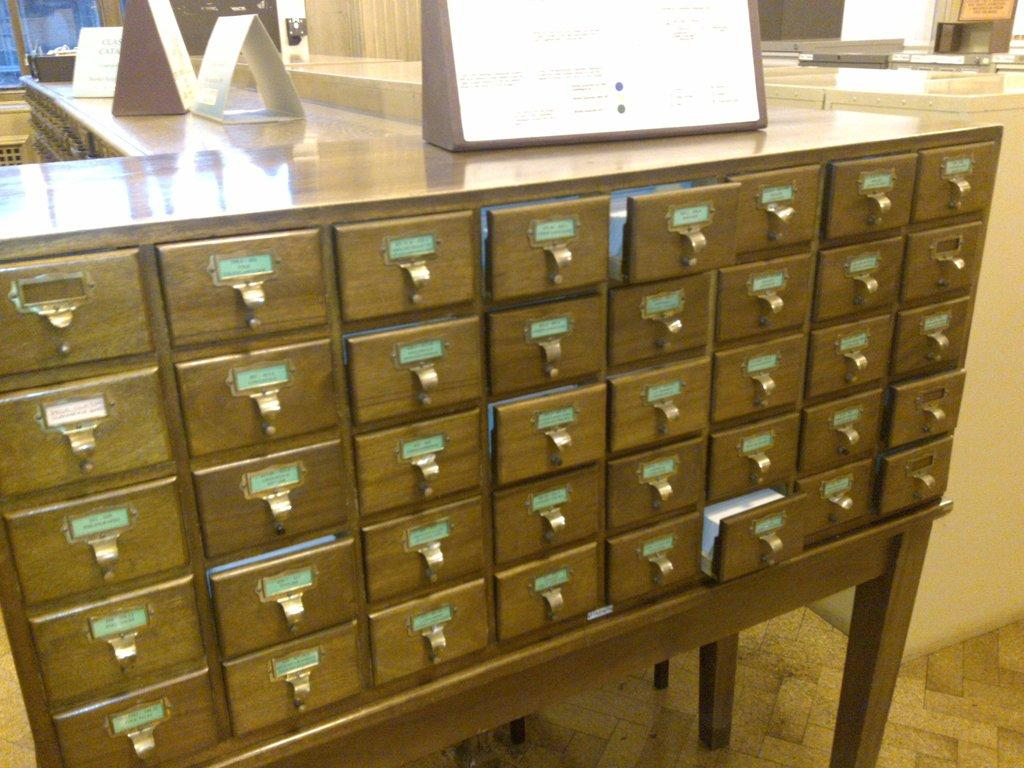What type of furniture is present in the image? There is a big table in the image. What feature can be seen on the table? The table has several locks on it. What else can be found on the table? There are objects on the table. How does the table jump in the image? The table does not jump in the image; it is stationary. What type of airport can be seen in the image? There is no airport present in the image. 